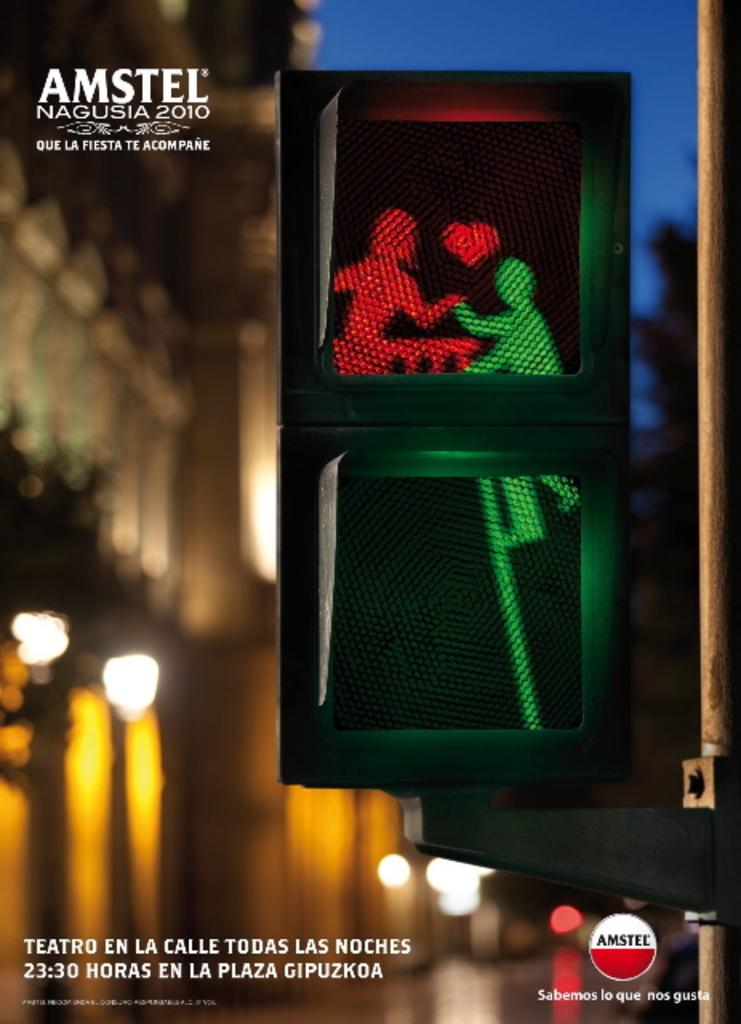Provide a one-sentence caption for the provided image. An advertisement in Spanish for Amstel Nagusia 2010. 